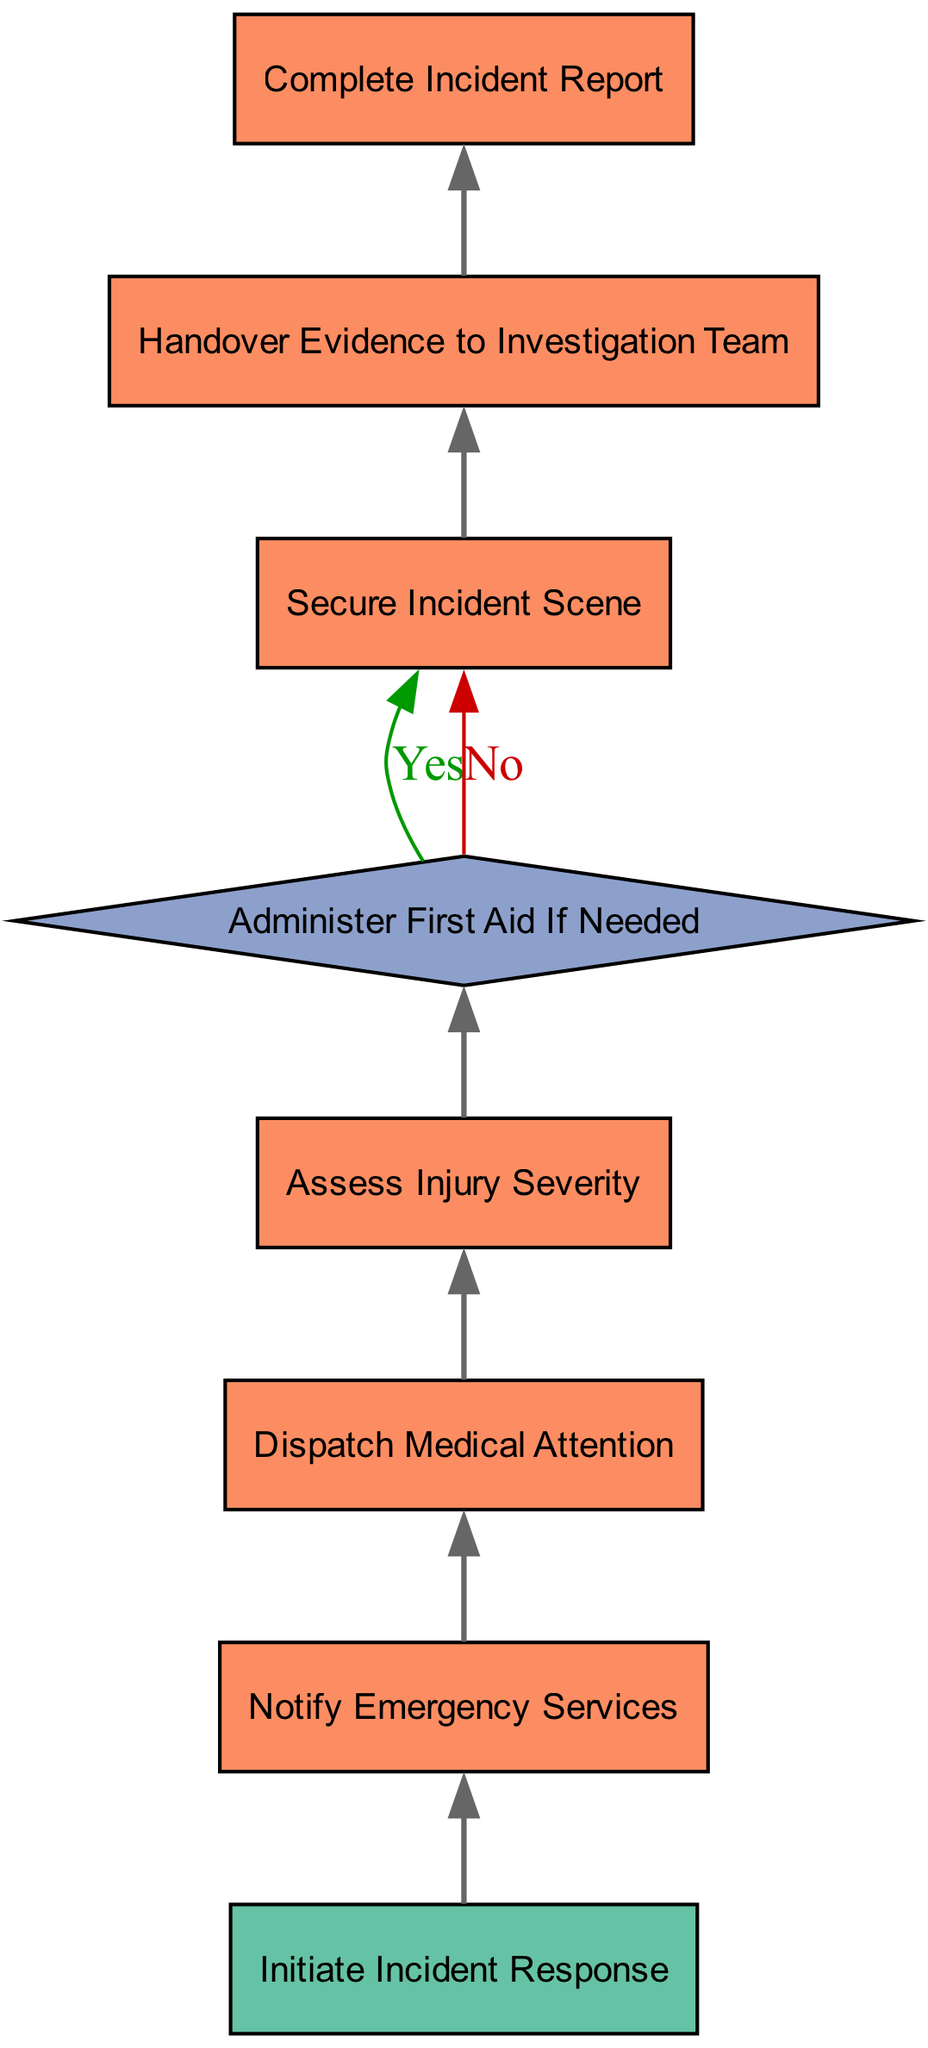What's the starting point of the workflow? The starting point of the workflow is identified as the node labeled "Initiate Incident Response". It serves as the entry point where the workflow begins.
Answer: Initiate Incident Response How many processes are there in the workflow? There are five processes in the workflow: "Complete Incident Report", "Handover Evidence to Investigation Team", "Secure Incident Scene", "Assess Injury Severity", and "Dispatch Medical Attention". By counting these specific labels, we can determine the total number of processes.
Answer: Five What happens if First Aid is needed? If First Aid is needed, the workflow proceeds to the next node labeled "Secure Incident Scene" as indicated by the 'Yes' edge from the "Administer First Aid If Needed" decision node.
Answer: Secure Incident Scene What is the final step of the workflow? The final step of the workflow is labeled "Complete Incident Report", which is the last node to be reached after going through the necessary incident response processes.
Answer: Complete Incident Report Which node follows "Notify Emergency Services"? The node that follows "Notify Emergency Services" is "Dispatch Medical Attention", as shown by the directed edge leading from the first node to the next.
Answer: Dispatch Medical Attention What decision needs to be made during the workflow? The decision that needs to be made during the workflow is whether to "Administer First Aid If Needed", which requires an assessment of the situation before proceeding.
Answer: Administer First Aid If Needed How many edges are there in total? There are six edges connecting the nodes in the workflow, as each transition between processes and decisions represents one directed edge leading to the next step.
Answer: Six What does the diagram indicate after "Assess Injury Severity"? After "Assess Injury Severity", the next step is the decision node "Administer First Aid If Needed", which will determine subsequent actions based on the assessment.
Answer: Administer First Aid If Needed What type of flowchart is represented in this diagram? The flowchart depicted in this diagram is a programming flowchart, which represents the workflow of incident response in a high-risk scenario from bottom to up.
Answer: Programming flowchart 